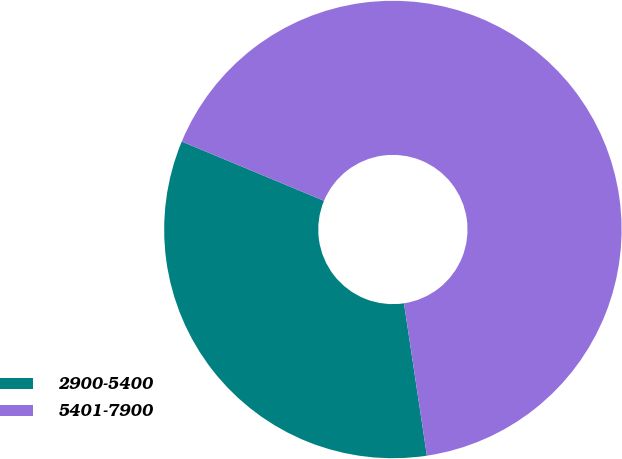Convert chart. <chart><loc_0><loc_0><loc_500><loc_500><pie_chart><fcel>2900-5400<fcel>5401-7900<nl><fcel>33.66%<fcel>66.34%<nl></chart> 